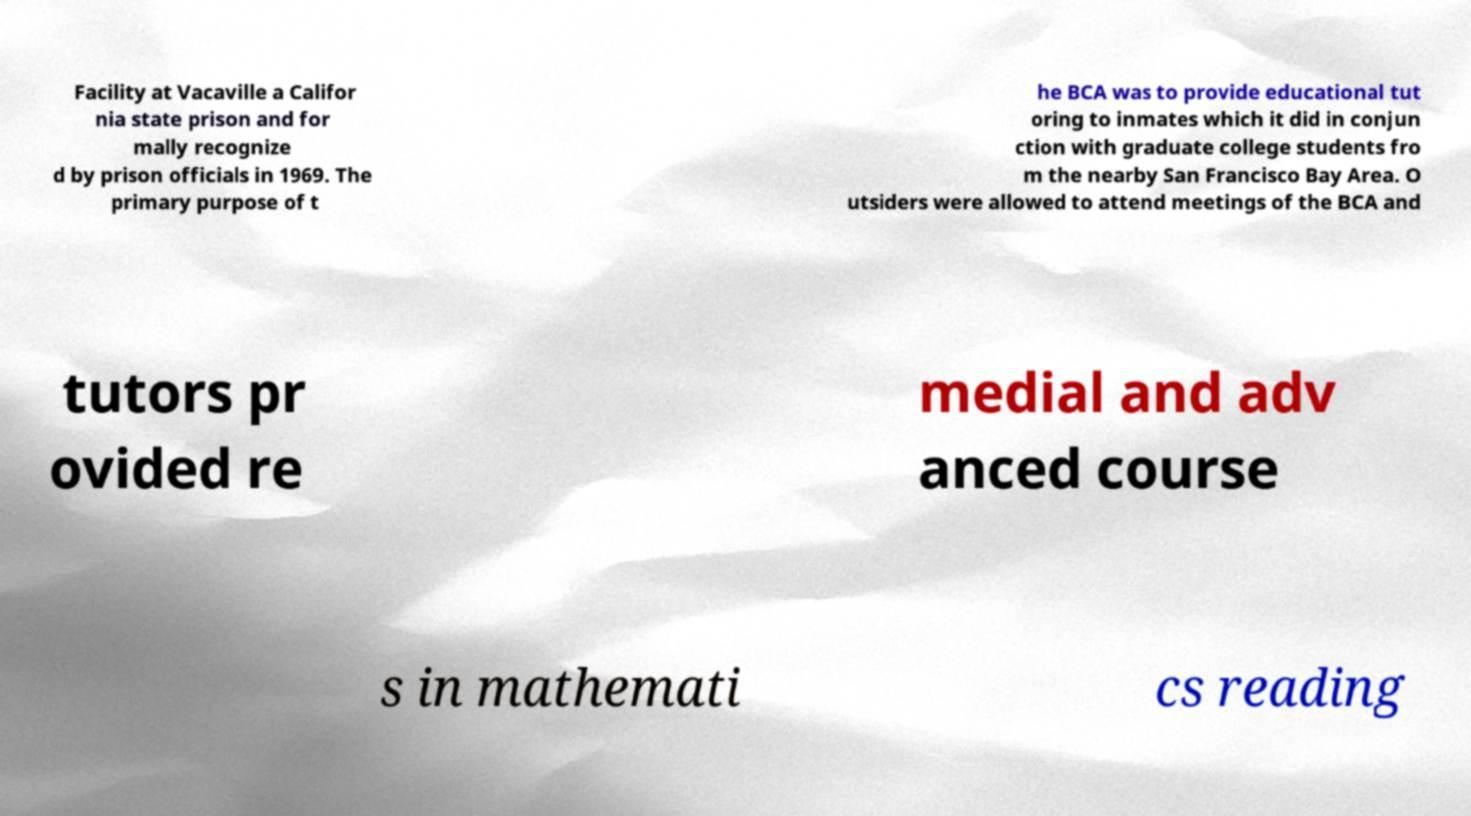What messages or text are displayed in this image? I need them in a readable, typed format. Facility at Vacaville a Califor nia state prison and for mally recognize d by prison officials in 1969. The primary purpose of t he BCA was to provide educational tut oring to inmates which it did in conjun ction with graduate college students fro m the nearby San Francisco Bay Area. O utsiders were allowed to attend meetings of the BCA and tutors pr ovided re medial and adv anced course s in mathemati cs reading 